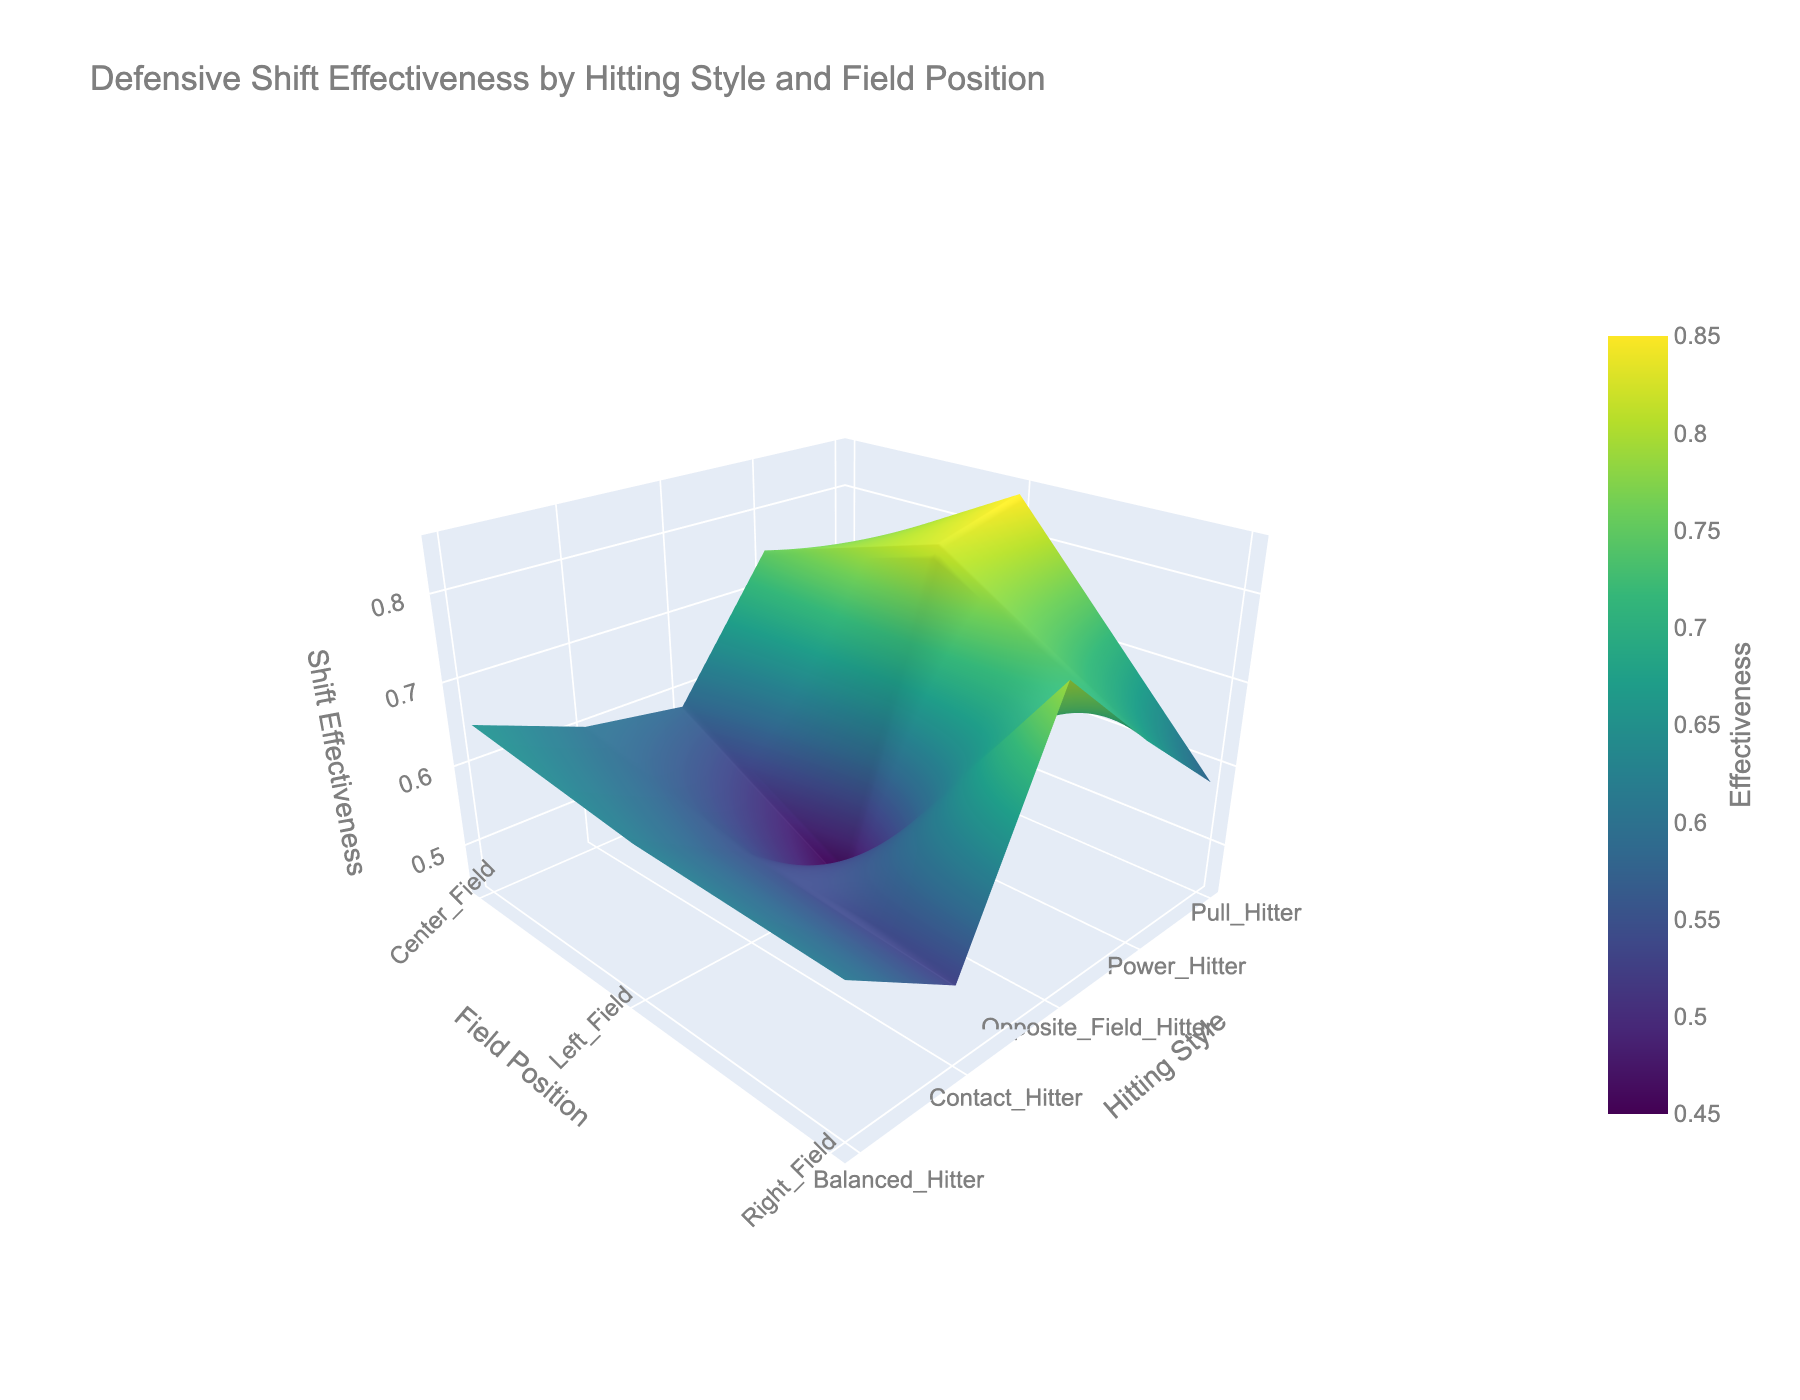What is the title of the figure? Look at the top center of the chart, the title is usually placed there.
Answer: Defensive Shift Effectiveness by Hitting Style and Field Position What are the axes labeled as? There are three axes: the x-axis, y-axis, and z-axis. The labels are usually around the axis lines.
Answer: Field Position (x), Hitting Style (y), Shift Effectiveness (z) Which hitting style has the highest shift effectiveness in Right Field? Observe the surface plot around the area where 'Right Field' on the x-axis intersects with the 'Shift Effectiveness' on the z-axis. Then look along the 'Hitting Style' on the y-axis.
Answer: Opposite_Field_Hitter What is the range of shift effectiveness for Balanced Hitters across all field positions? Look at the 'Balanced_Hitter' row on the y-axis of the surface plot and observe the 'Shift Effectiveness' values on the z-axis for 'Left Field', 'Center Field', and 'Right Field'.
Answer: 0.61 to 0.65 Which hitting style and field position combination has the lowest shift effectiveness? Find the lowest point on the surface plot, noting the corresponding hitting style on the y-axis and field position on the x-axis.
Answer: Opposite_Field_Hitter, Left_Field Which hitting style shows the most significant variability in shift effectiveness across different field positions? Observe the range of values on the z-axis for each hitting style on the y-axis. Identify the style with the widest range.
Answer: Pull_Hitter (range: 0.85 - 0.58) 